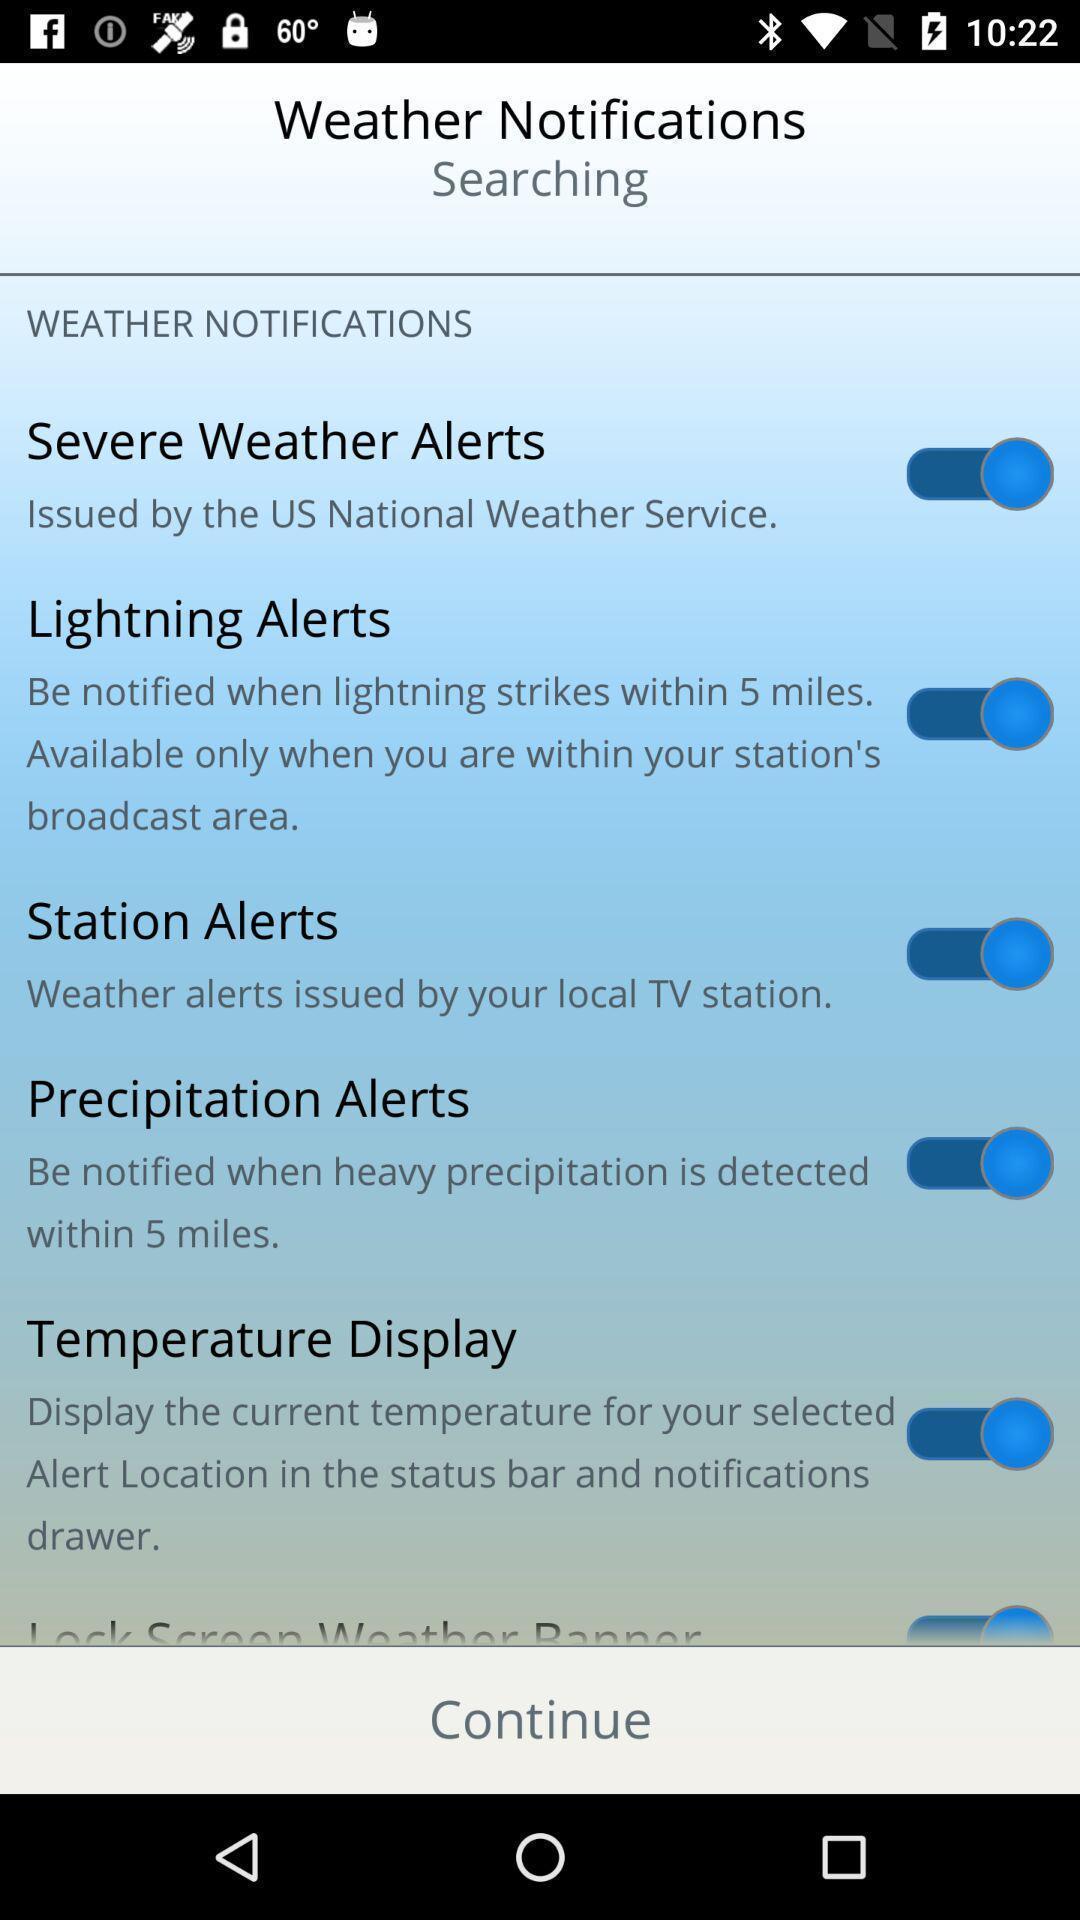Describe the content in this image. Weather notifications page. 